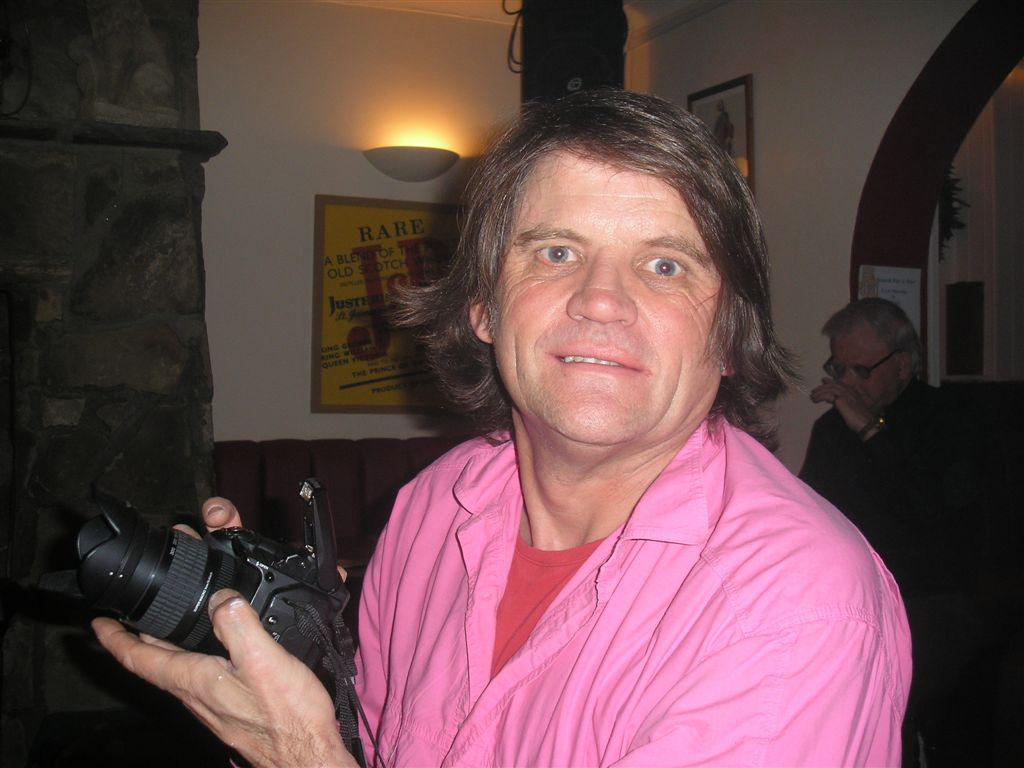How many persons are present in the image? There are two persons in the image. What is one of the persons holding in the image? One of the persons is holding a camera. What can be seen in the background of the image? There is a wall, a light, and a poster in the background of the image. What type of bread is being cooked by the person in the image? There is no person cooking bread in the image. What type of war is depicted in the poster in the background of the image? There is no war depicted in the poster in the background of the image. 